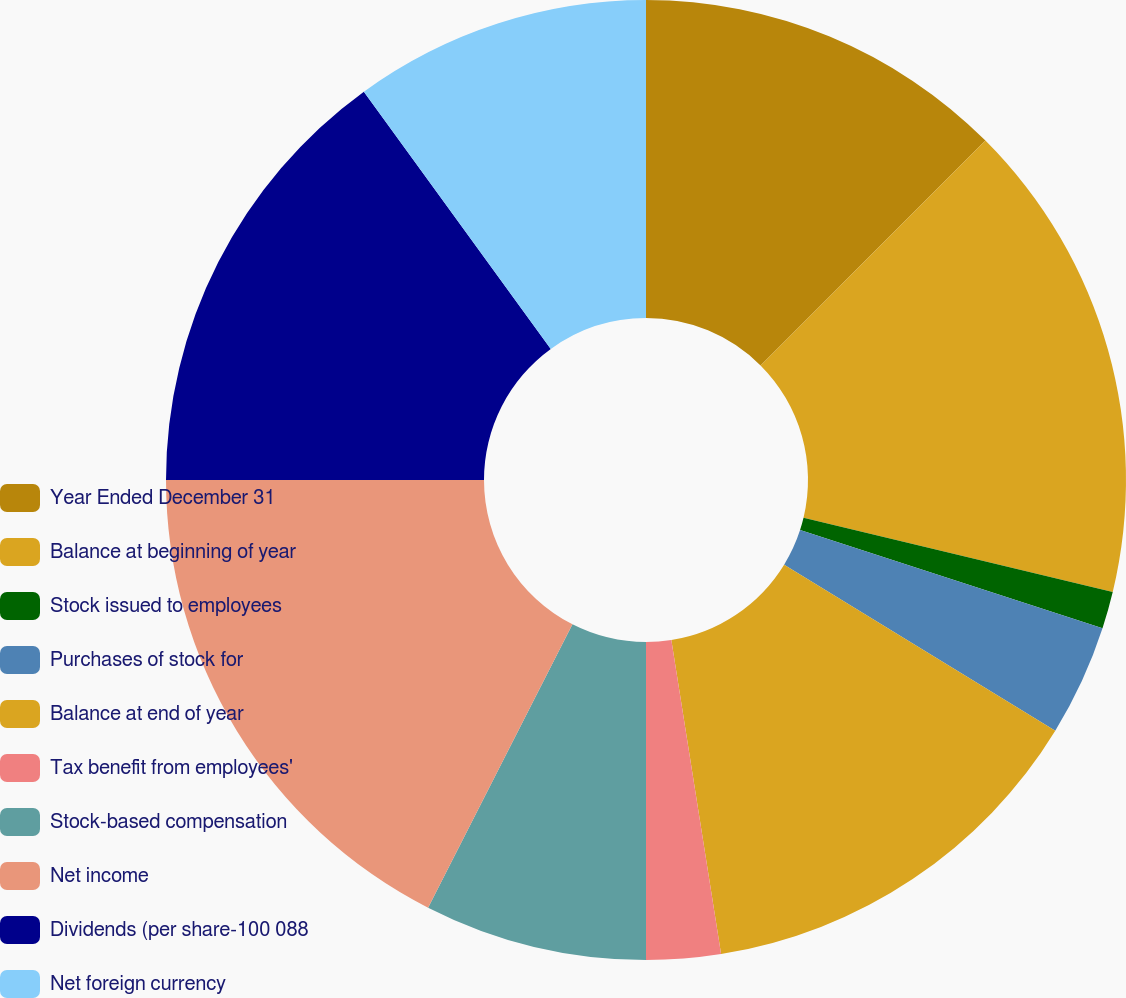Convert chart. <chart><loc_0><loc_0><loc_500><loc_500><pie_chart><fcel>Year Ended December 31<fcel>Balance at beginning of year<fcel>Stock issued to employees<fcel>Purchases of stock for<fcel>Balance at end of year<fcel>Tax benefit from employees'<fcel>Stock-based compensation<fcel>Net income<fcel>Dividends (per share-100 088<fcel>Net foreign currency<nl><fcel>12.5%<fcel>16.25%<fcel>1.25%<fcel>3.75%<fcel>13.75%<fcel>2.5%<fcel>7.5%<fcel>17.5%<fcel>15.0%<fcel>10.0%<nl></chart> 